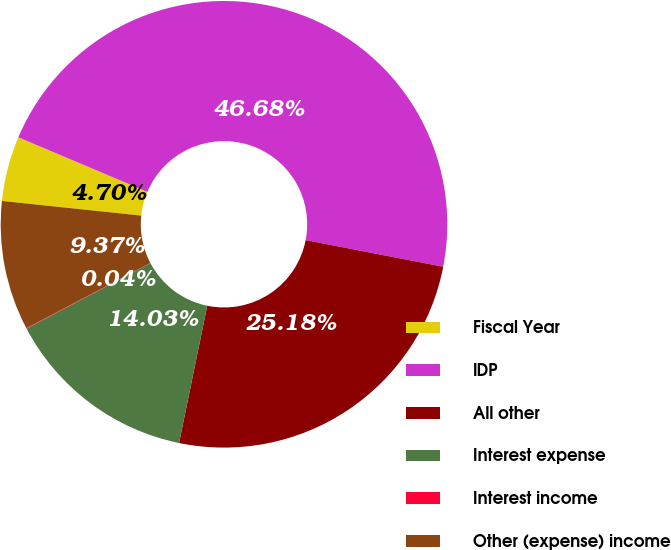Convert chart. <chart><loc_0><loc_0><loc_500><loc_500><pie_chart><fcel>Fiscal Year<fcel>IDP<fcel>All other<fcel>Interest expense<fcel>Interest income<fcel>Other (expense) income<nl><fcel>4.7%<fcel>46.68%<fcel>25.18%<fcel>14.03%<fcel>0.04%<fcel>9.37%<nl></chart> 